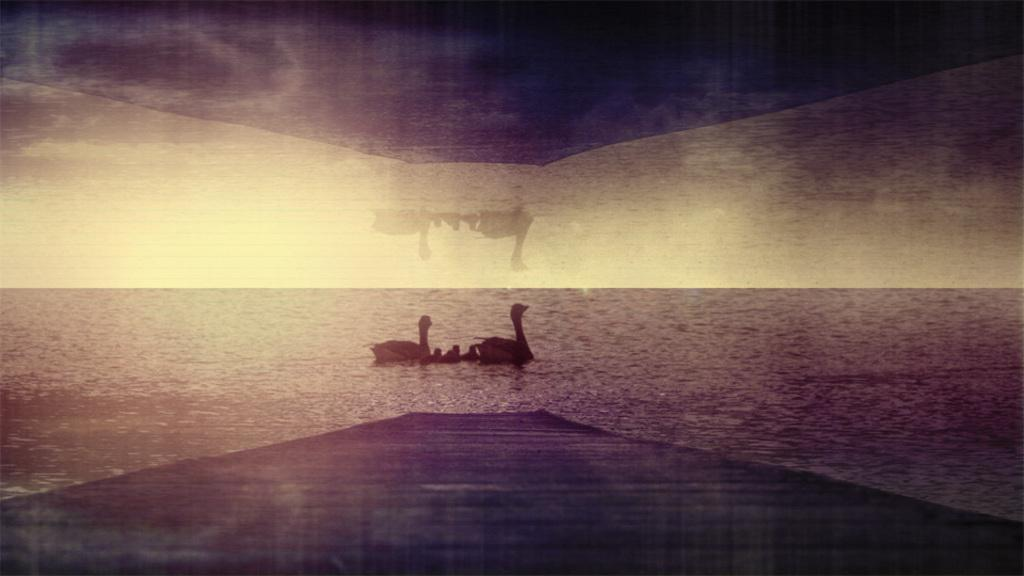What type of picture is present in the image? The image contains an edited picture. What is the subject of the edited picture? The edited picture depicts birds on the water. What type of stitch is used to create the canvas in the image? There is no canvas or stitching present in the image; it features an edited picture of birds on the water. 